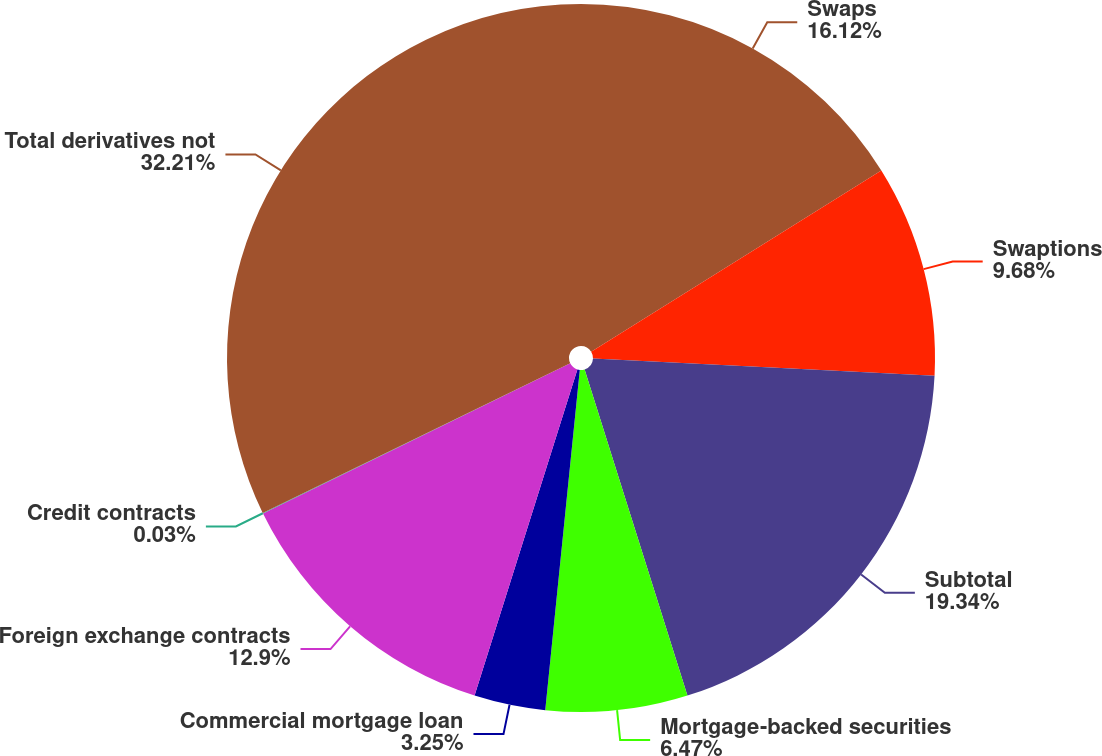Convert chart to OTSL. <chart><loc_0><loc_0><loc_500><loc_500><pie_chart><fcel>Swaps<fcel>Swaptions<fcel>Subtotal<fcel>Mortgage-backed securities<fcel>Commercial mortgage loan<fcel>Foreign exchange contracts<fcel>Credit contracts<fcel>Total derivatives not<nl><fcel>16.12%<fcel>9.68%<fcel>19.34%<fcel>6.47%<fcel>3.25%<fcel>12.9%<fcel>0.03%<fcel>32.21%<nl></chart> 